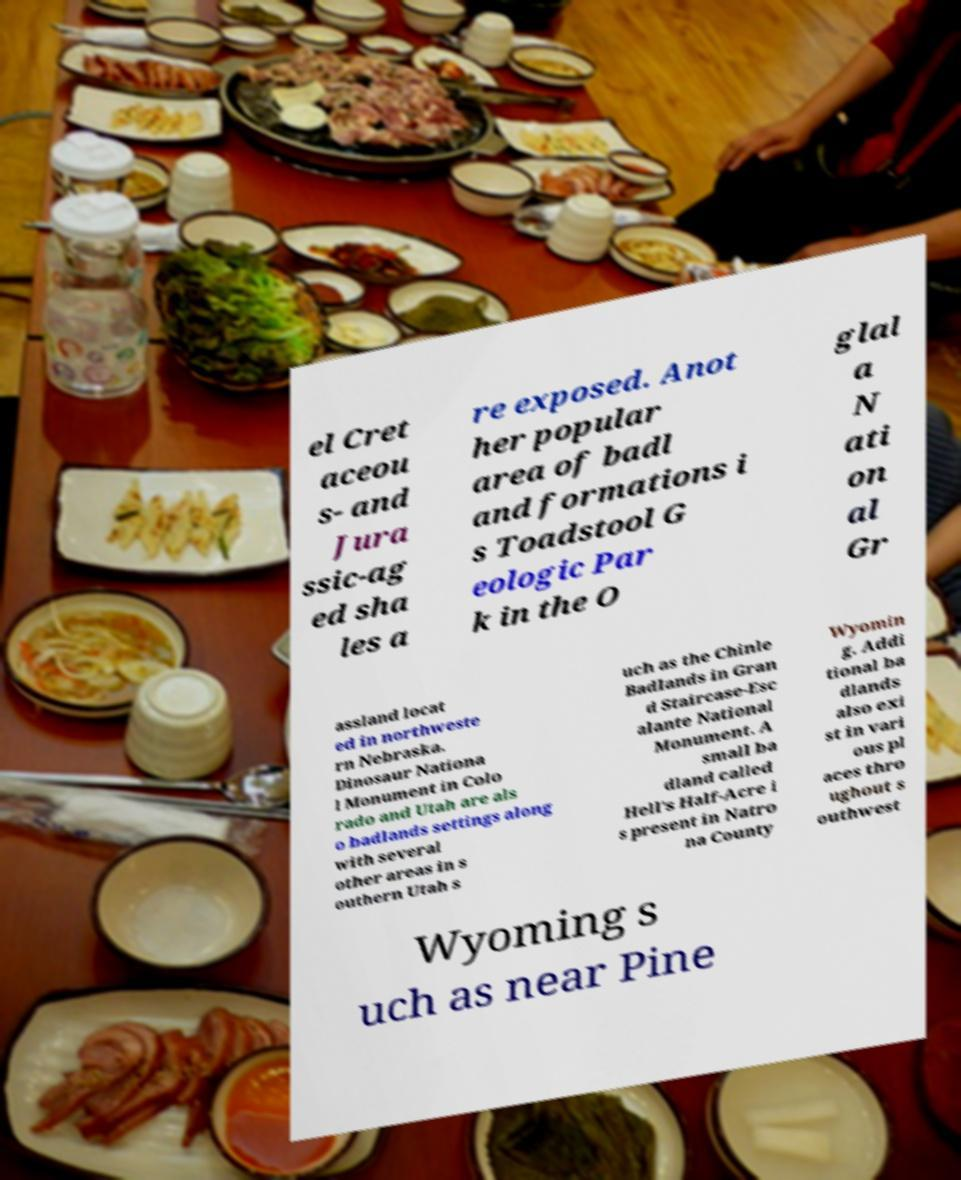Can you accurately transcribe the text from the provided image for me? el Cret aceou s- and Jura ssic-ag ed sha les a re exposed. Anot her popular area of badl and formations i s Toadstool G eologic Par k in the O glal a N ati on al Gr assland locat ed in northweste rn Nebraska. Dinosaur Nationa l Monument in Colo rado and Utah are als o badlands settings along with several other areas in s outhern Utah s uch as the Chinle Badlands in Gran d Staircase-Esc alante National Monument. A small ba dland called Hell's Half-Acre i s present in Natro na County Wyomin g. Addi tional ba dlands also exi st in vari ous pl aces thro ughout s outhwest Wyoming s uch as near Pine 